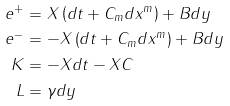<formula> <loc_0><loc_0><loc_500><loc_500>e ^ { + } & = X \left ( d t + C _ { m } d x ^ { m } \right ) + B d y \\ e ^ { - } & = - X \left ( d t + C _ { m } d x ^ { m } \right ) + B d y \\ K & = - X d t - X C \\ L & = \gamma d y</formula> 